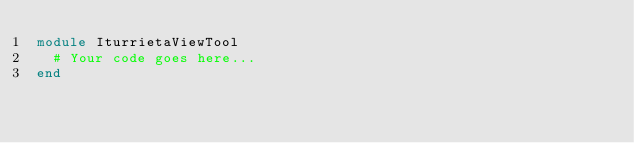Convert code to text. <code><loc_0><loc_0><loc_500><loc_500><_Ruby_>module IturrietaViewTool
  # Your code goes here...
end
</code> 